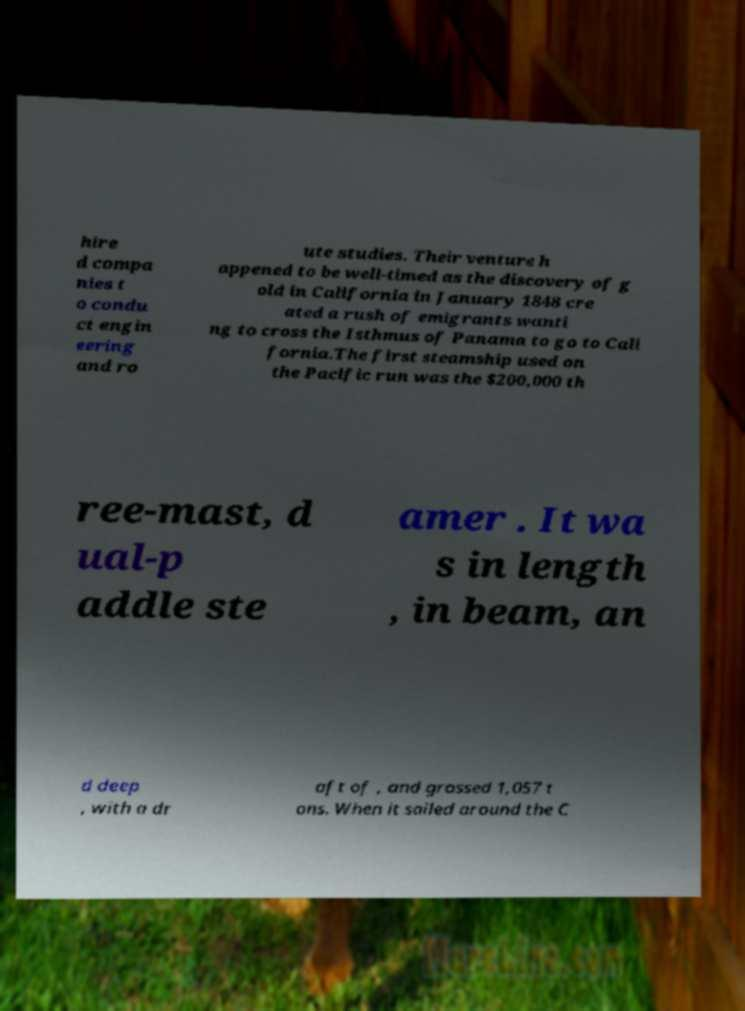For documentation purposes, I need the text within this image transcribed. Could you provide that? hire d compa nies t o condu ct engin eering and ro ute studies. Their venture h appened to be well-timed as the discovery of g old in California in January 1848 cre ated a rush of emigrants wanti ng to cross the Isthmus of Panama to go to Cali fornia.The first steamship used on the Pacific run was the $200,000 th ree-mast, d ual-p addle ste amer . It wa s in length , in beam, an d deep , with a dr aft of , and grossed 1,057 t ons. When it sailed around the C 